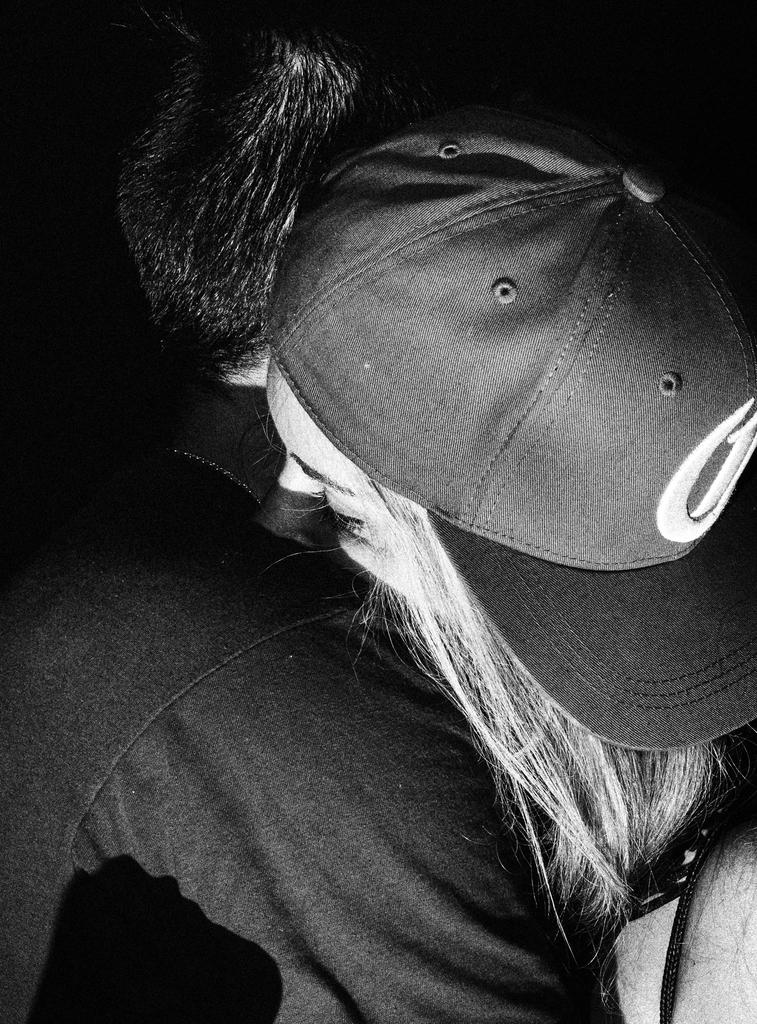How many people are wearing dresses in the image? There are two people with dresses in the image. What type of headwear is worn by one of the people in the image? One person is wearing a cap in the image. What is the color scheme of the image? The image is black and white. What type of celery can be seen growing in the image? There is no celery present in the image; it features two people with dresses and one person with a cap. How many legs does the person with the cap have in the image? The person with the cap is a human, and humans typically have two legs. However, this question cannot be definitively answered from the image alone, as it does not show the person's legs. 